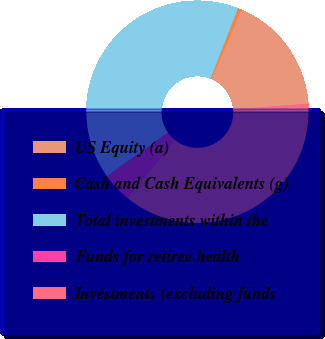<chart> <loc_0><loc_0><loc_500><loc_500><pie_chart><fcel>US Equity (a)<fcel>Cash and Cash Equivalents (g)<fcel>Total investments within the<fcel>Funds for retiree health<fcel>Investments (excluding funds<nl><fcel>17.35%<fcel>0.56%<fcel>40.77%<fcel>4.28%<fcel>37.05%<nl></chart> 